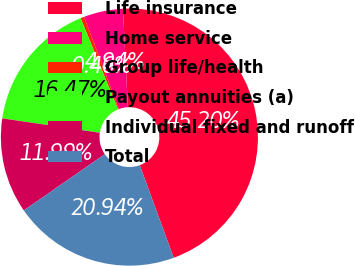<chart> <loc_0><loc_0><loc_500><loc_500><pie_chart><fcel>Life insurance<fcel>Home service<fcel>Group life/health<fcel>Payout annuities (a)<fcel>Individual fixed and runoff<fcel>Total<nl><fcel>45.2%<fcel>4.94%<fcel>0.46%<fcel>16.47%<fcel>11.99%<fcel>20.94%<nl></chart> 